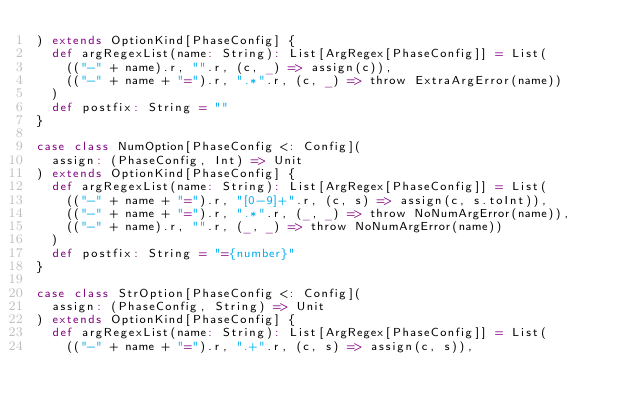Convert code to text. <code><loc_0><loc_0><loc_500><loc_500><_Scala_>) extends OptionKind[PhaseConfig] {
  def argRegexList(name: String): List[ArgRegex[PhaseConfig]] = List(
    (("-" + name).r, "".r, (c, _) => assign(c)),
    (("-" + name + "=").r, ".*".r, (c, _) => throw ExtraArgError(name))
  )
  def postfix: String = ""
}

case class NumOption[PhaseConfig <: Config](
  assign: (PhaseConfig, Int) => Unit
) extends OptionKind[PhaseConfig] {
  def argRegexList(name: String): List[ArgRegex[PhaseConfig]] = List(
    (("-" + name + "=").r, "[0-9]+".r, (c, s) => assign(c, s.toInt)),
    (("-" + name + "=").r, ".*".r, (_, _) => throw NoNumArgError(name)),
    (("-" + name).r, "".r, (_, _) => throw NoNumArgError(name))
  )
  def postfix: String = "={number}"
}

case class StrOption[PhaseConfig <: Config](
  assign: (PhaseConfig, String) => Unit
) extends OptionKind[PhaseConfig] {
  def argRegexList(name: String): List[ArgRegex[PhaseConfig]] = List(
    (("-" + name + "=").r, ".+".r, (c, s) => assign(c, s)),</code> 